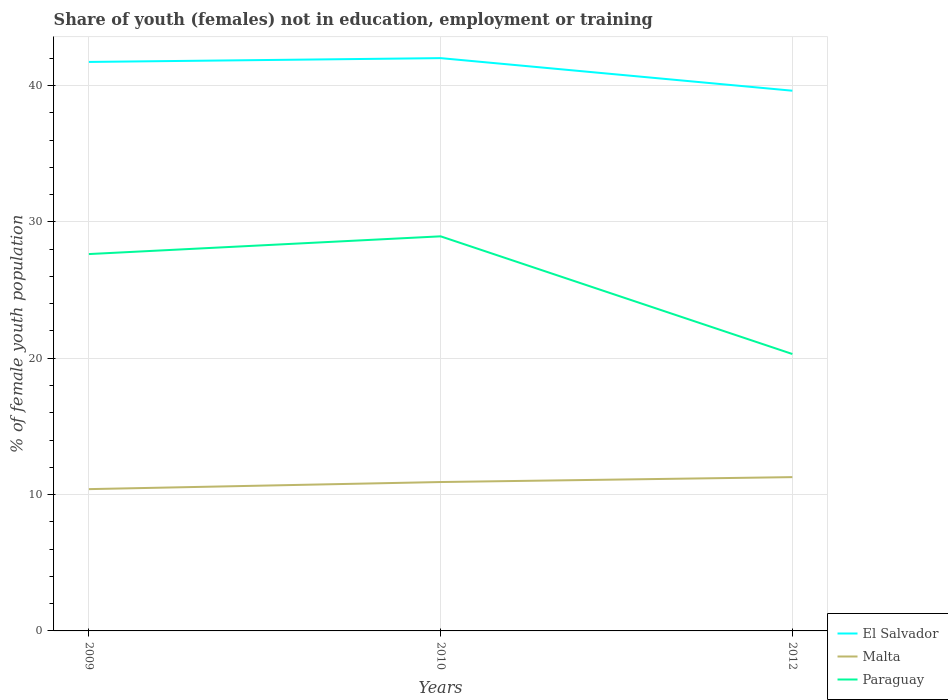Is the number of lines equal to the number of legend labels?
Ensure brevity in your answer.  Yes. Across all years, what is the maximum percentage of unemployed female population in in Malta?
Keep it short and to the point. 10.4. What is the total percentage of unemployed female population in in Malta in the graph?
Give a very brief answer. -0.88. What is the difference between the highest and the second highest percentage of unemployed female population in in Paraguay?
Provide a short and direct response. 8.63. Is the percentage of unemployed female population in in Paraguay strictly greater than the percentage of unemployed female population in in Malta over the years?
Provide a succinct answer. No. How many lines are there?
Ensure brevity in your answer.  3. What is the difference between two consecutive major ticks on the Y-axis?
Keep it short and to the point. 10. How many legend labels are there?
Give a very brief answer. 3. What is the title of the graph?
Your answer should be compact. Share of youth (females) not in education, employment or training. Does "Upper middle income" appear as one of the legend labels in the graph?
Make the answer very short. No. What is the label or title of the Y-axis?
Your response must be concise. % of female youth population. What is the % of female youth population of El Salvador in 2009?
Offer a terse response. 41.73. What is the % of female youth population in Malta in 2009?
Ensure brevity in your answer.  10.4. What is the % of female youth population of Paraguay in 2009?
Give a very brief answer. 27.64. What is the % of female youth population in El Salvador in 2010?
Your answer should be compact. 42.01. What is the % of female youth population in Malta in 2010?
Your response must be concise. 10.92. What is the % of female youth population of Paraguay in 2010?
Ensure brevity in your answer.  28.94. What is the % of female youth population of El Salvador in 2012?
Give a very brief answer. 39.62. What is the % of female youth population of Malta in 2012?
Offer a very short reply. 11.28. What is the % of female youth population of Paraguay in 2012?
Offer a very short reply. 20.31. Across all years, what is the maximum % of female youth population of El Salvador?
Make the answer very short. 42.01. Across all years, what is the maximum % of female youth population in Malta?
Make the answer very short. 11.28. Across all years, what is the maximum % of female youth population of Paraguay?
Your answer should be compact. 28.94. Across all years, what is the minimum % of female youth population in El Salvador?
Make the answer very short. 39.62. Across all years, what is the minimum % of female youth population of Malta?
Provide a short and direct response. 10.4. Across all years, what is the minimum % of female youth population in Paraguay?
Ensure brevity in your answer.  20.31. What is the total % of female youth population of El Salvador in the graph?
Provide a succinct answer. 123.36. What is the total % of female youth population of Malta in the graph?
Offer a terse response. 32.6. What is the total % of female youth population of Paraguay in the graph?
Your response must be concise. 76.89. What is the difference between the % of female youth population of El Salvador in 2009 and that in 2010?
Your response must be concise. -0.28. What is the difference between the % of female youth population in Malta in 2009 and that in 2010?
Keep it short and to the point. -0.52. What is the difference between the % of female youth population in Paraguay in 2009 and that in 2010?
Make the answer very short. -1.3. What is the difference between the % of female youth population of El Salvador in 2009 and that in 2012?
Your response must be concise. 2.11. What is the difference between the % of female youth population of Malta in 2009 and that in 2012?
Your answer should be compact. -0.88. What is the difference between the % of female youth population in Paraguay in 2009 and that in 2012?
Provide a short and direct response. 7.33. What is the difference between the % of female youth population of El Salvador in 2010 and that in 2012?
Your answer should be very brief. 2.39. What is the difference between the % of female youth population in Malta in 2010 and that in 2012?
Your response must be concise. -0.36. What is the difference between the % of female youth population of Paraguay in 2010 and that in 2012?
Make the answer very short. 8.63. What is the difference between the % of female youth population of El Salvador in 2009 and the % of female youth population of Malta in 2010?
Provide a succinct answer. 30.81. What is the difference between the % of female youth population in El Salvador in 2009 and the % of female youth population in Paraguay in 2010?
Make the answer very short. 12.79. What is the difference between the % of female youth population in Malta in 2009 and the % of female youth population in Paraguay in 2010?
Your answer should be compact. -18.54. What is the difference between the % of female youth population in El Salvador in 2009 and the % of female youth population in Malta in 2012?
Keep it short and to the point. 30.45. What is the difference between the % of female youth population of El Salvador in 2009 and the % of female youth population of Paraguay in 2012?
Offer a terse response. 21.42. What is the difference between the % of female youth population of Malta in 2009 and the % of female youth population of Paraguay in 2012?
Provide a short and direct response. -9.91. What is the difference between the % of female youth population in El Salvador in 2010 and the % of female youth population in Malta in 2012?
Your answer should be very brief. 30.73. What is the difference between the % of female youth population of El Salvador in 2010 and the % of female youth population of Paraguay in 2012?
Ensure brevity in your answer.  21.7. What is the difference between the % of female youth population in Malta in 2010 and the % of female youth population in Paraguay in 2012?
Provide a short and direct response. -9.39. What is the average % of female youth population of El Salvador per year?
Provide a short and direct response. 41.12. What is the average % of female youth population in Malta per year?
Your answer should be very brief. 10.87. What is the average % of female youth population of Paraguay per year?
Your response must be concise. 25.63. In the year 2009, what is the difference between the % of female youth population in El Salvador and % of female youth population in Malta?
Give a very brief answer. 31.33. In the year 2009, what is the difference between the % of female youth population of El Salvador and % of female youth population of Paraguay?
Your answer should be compact. 14.09. In the year 2009, what is the difference between the % of female youth population of Malta and % of female youth population of Paraguay?
Offer a very short reply. -17.24. In the year 2010, what is the difference between the % of female youth population in El Salvador and % of female youth population in Malta?
Your response must be concise. 31.09. In the year 2010, what is the difference between the % of female youth population of El Salvador and % of female youth population of Paraguay?
Offer a terse response. 13.07. In the year 2010, what is the difference between the % of female youth population of Malta and % of female youth population of Paraguay?
Ensure brevity in your answer.  -18.02. In the year 2012, what is the difference between the % of female youth population in El Salvador and % of female youth population in Malta?
Provide a short and direct response. 28.34. In the year 2012, what is the difference between the % of female youth population of El Salvador and % of female youth population of Paraguay?
Provide a short and direct response. 19.31. In the year 2012, what is the difference between the % of female youth population in Malta and % of female youth population in Paraguay?
Your answer should be very brief. -9.03. What is the ratio of the % of female youth population in Malta in 2009 to that in 2010?
Offer a terse response. 0.95. What is the ratio of the % of female youth population of Paraguay in 2009 to that in 2010?
Offer a very short reply. 0.96. What is the ratio of the % of female youth population of El Salvador in 2009 to that in 2012?
Offer a very short reply. 1.05. What is the ratio of the % of female youth population in Malta in 2009 to that in 2012?
Provide a short and direct response. 0.92. What is the ratio of the % of female youth population of Paraguay in 2009 to that in 2012?
Ensure brevity in your answer.  1.36. What is the ratio of the % of female youth population in El Salvador in 2010 to that in 2012?
Provide a short and direct response. 1.06. What is the ratio of the % of female youth population in Malta in 2010 to that in 2012?
Your answer should be compact. 0.97. What is the ratio of the % of female youth population of Paraguay in 2010 to that in 2012?
Offer a terse response. 1.42. What is the difference between the highest and the second highest % of female youth population in El Salvador?
Keep it short and to the point. 0.28. What is the difference between the highest and the second highest % of female youth population in Malta?
Ensure brevity in your answer.  0.36. What is the difference between the highest and the second highest % of female youth population in Paraguay?
Offer a very short reply. 1.3. What is the difference between the highest and the lowest % of female youth population in El Salvador?
Offer a very short reply. 2.39. What is the difference between the highest and the lowest % of female youth population of Malta?
Provide a short and direct response. 0.88. What is the difference between the highest and the lowest % of female youth population in Paraguay?
Offer a very short reply. 8.63. 